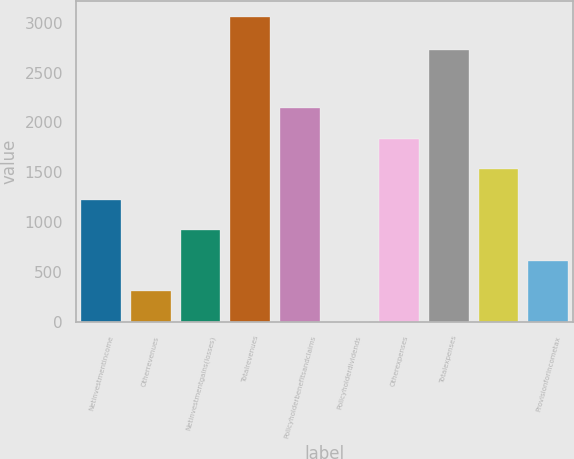Convert chart to OTSL. <chart><loc_0><loc_0><loc_500><loc_500><bar_chart><fcel>Netinvestmentincome<fcel>Otherrevenues<fcel>Netinvestmentgains(losses)<fcel>Totalrevenues<fcel>Policyholderbenefitsandclaims<fcel>Policyholderdividends<fcel>Otherexpenses<fcel>Totalexpenses<fcel>Unnamed: 8<fcel>Provisionforincometax<nl><fcel>1227<fcel>310.5<fcel>921.5<fcel>3060<fcel>2143.5<fcel>5<fcel>1838<fcel>2728<fcel>1532.5<fcel>616<nl></chart> 